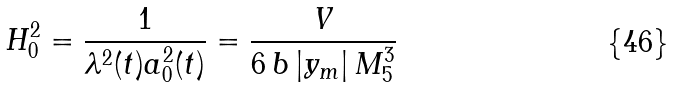Convert formula to latex. <formula><loc_0><loc_0><loc_500><loc_500>H _ { 0 } ^ { 2 } = \frac { 1 } { \lambda ^ { 2 } ( t ) a _ { 0 } ^ { 2 } ( t ) } = \frac { V } { 6 \, b \, | y _ { m } | \, M _ { 5 } ^ { 3 } } \,</formula> 